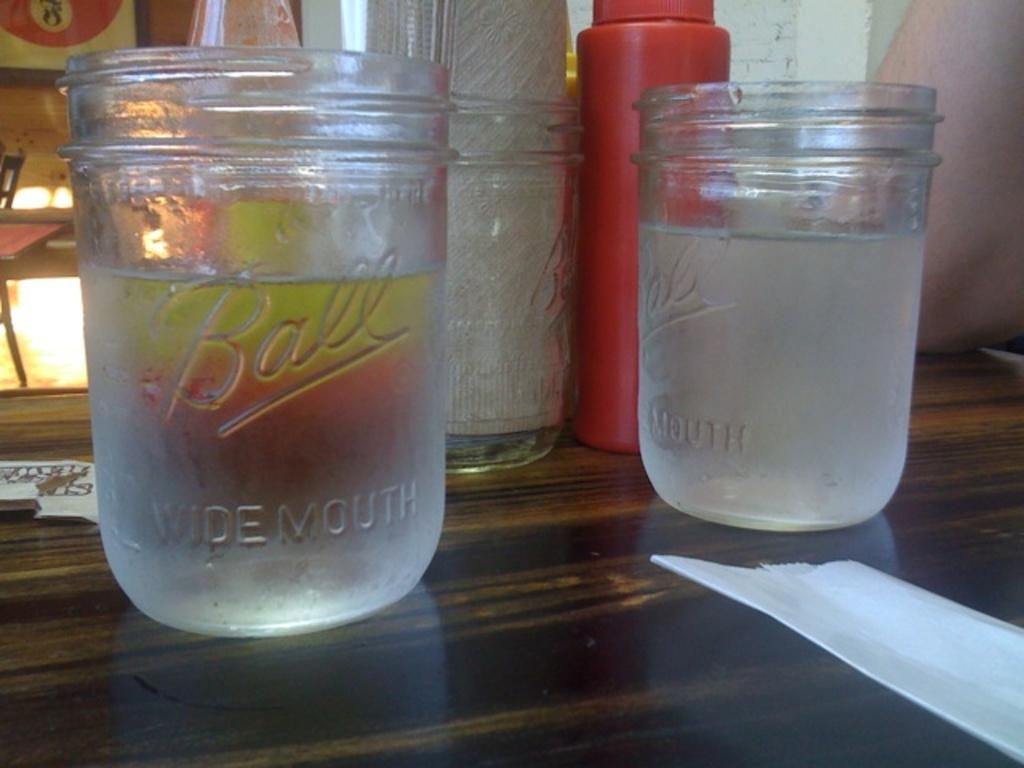<image>
Share a concise interpretation of the image provided. Ball glasses on the table including two that are filled with water. 